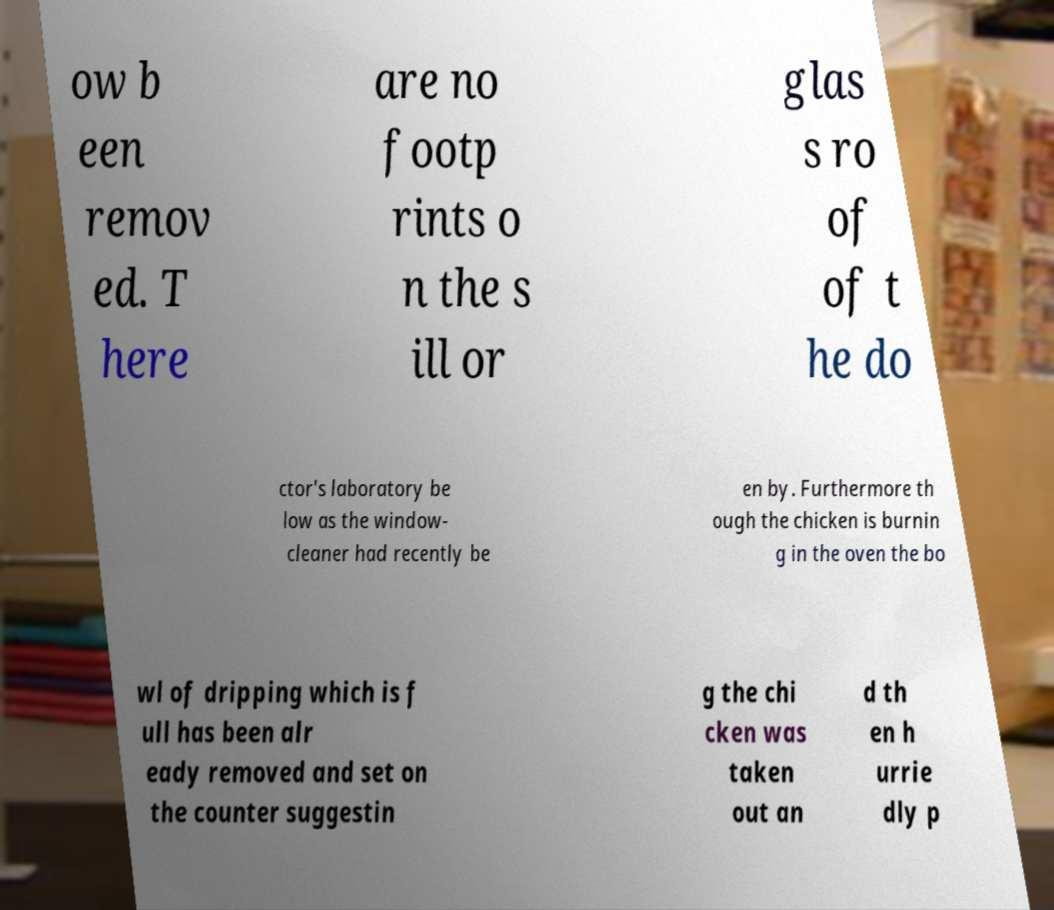Could you assist in decoding the text presented in this image and type it out clearly? ow b een remov ed. T here are no footp rints o n the s ill or glas s ro of of t he do ctor's laboratory be low as the window- cleaner had recently be en by. Furthermore th ough the chicken is burnin g in the oven the bo wl of dripping which is f ull has been alr eady removed and set on the counter suggestin g the chi cken was taken out an d th en h urrie dly p 